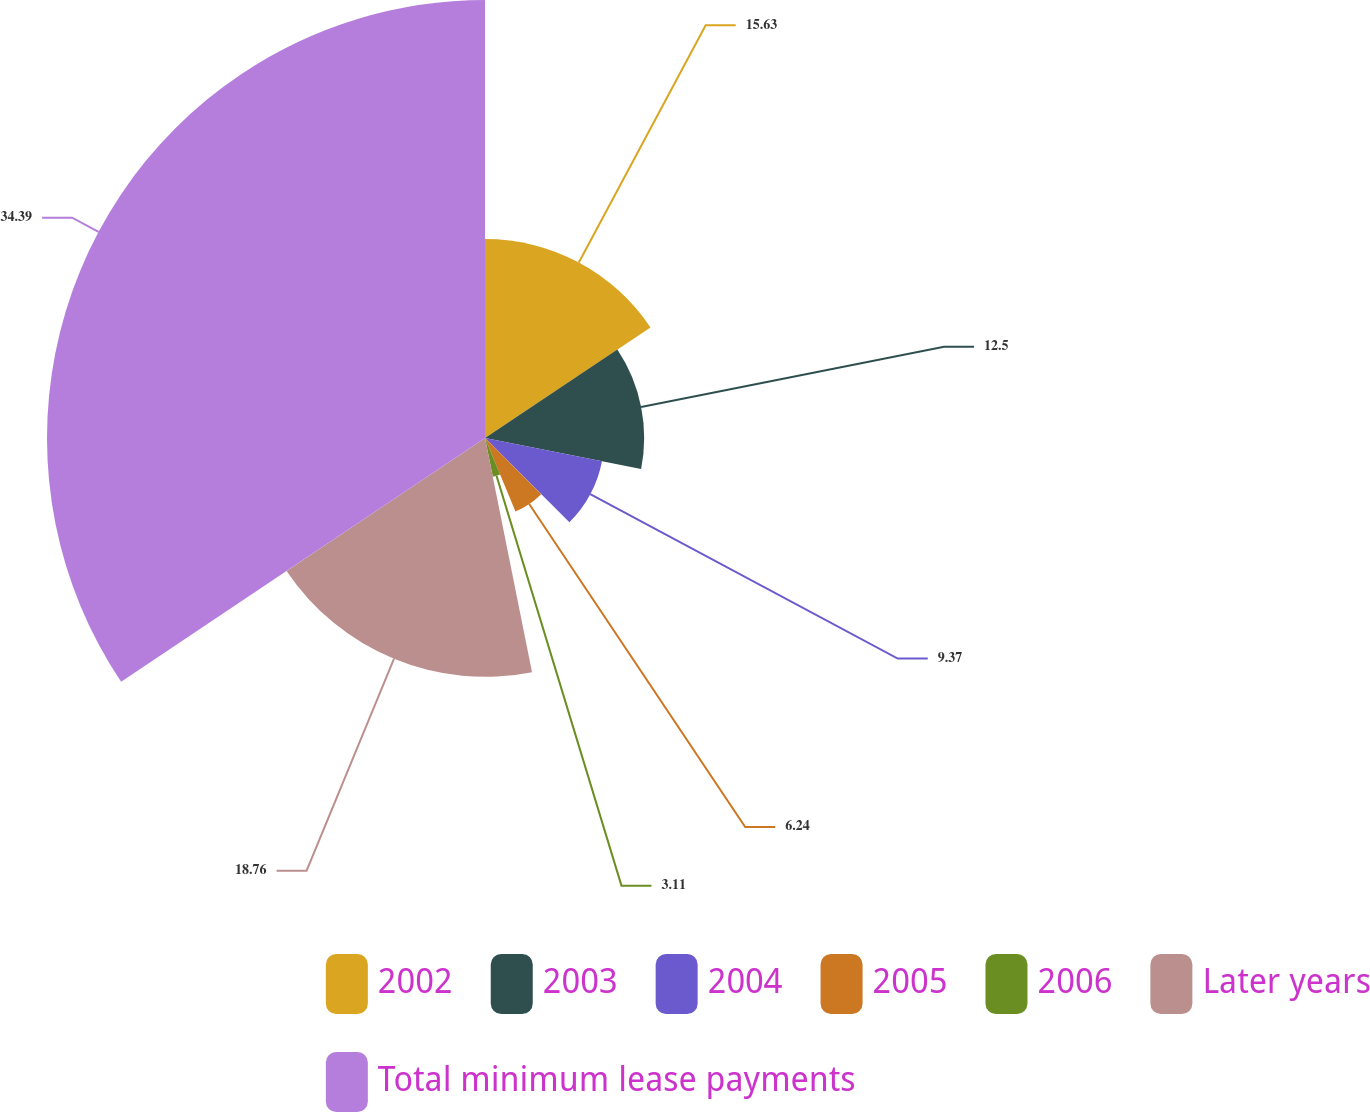<chart> <loc_0><loc_0><loc_500><loc_500><pie_chart><fcel>2002<fcel>2003<fcel>2004<fcel>2005<fcel>2006<fcel>Later years<fcel>Total minimum lease payments<nl><fcel>15.63%<fcel>12.5%<fcel>9.37%<fcel>6.24%<fcel>3.11%<fcel>18.76%<fcel>34.4%<nl></chart> 